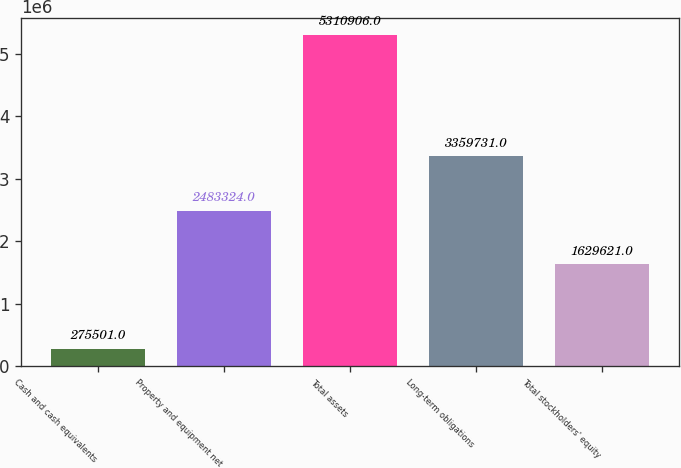<chart> <loc_0><loc_0><loc_500><loc_500><bar_chart><fcel>Cash and cash equivalents<fcel>Property and equipment net<fcel>Total assets<fcel>Long-term obligations<fcel>Total stockholders' equity<nl><fcel>275501<fcel>2.48332e+06<fcel>5.31091e+06<fcel>3.35973e+06<fcel>1.62962e+06<nl></chart> 